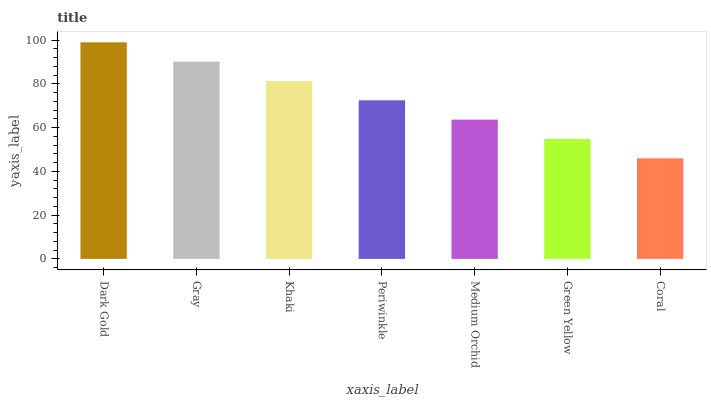Is Coral the minimum?
Answer yes or no. Yes. Is Dark Gold the maximum?
Answer yes or no. Yes. Is Gray the minimum?
Answer yes or no. No. Is Gray the maximum?
Answer yes or no. No. Is Dark Gold greater than Gray?
Answer yes or no. Yes. Is Gray less than Dark Gold?
Answer yes or no. Yes. Is Gray greater than Dark Gold?
Answer yes or no. No. Is Dark Gold less than Gray?
Answer yes or no. No. Is Periwinkle the high median?
Answer yes or no. Yes. Is Periwinkle the low median?
Answer yes or no. Yes. Is Khaki the high median?
Answer yes or no. No. Is Green Yellow the low median?
Answer yes or no. No. 